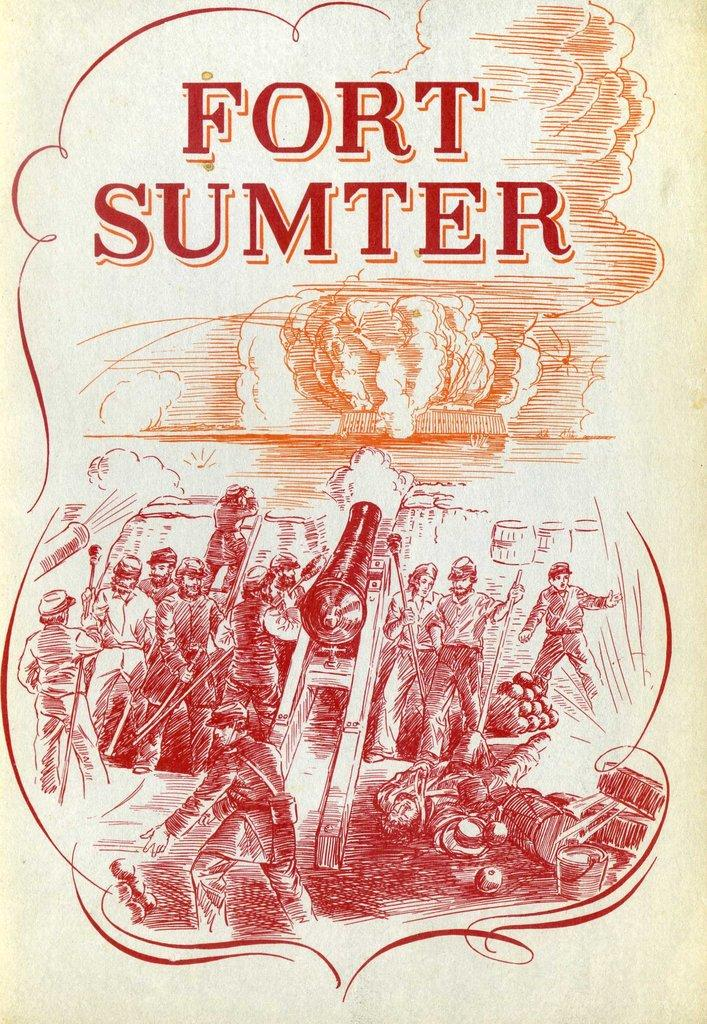Provide a one-sentence caption for the provided image. A red and orange Fort Sumter sign for a book. 